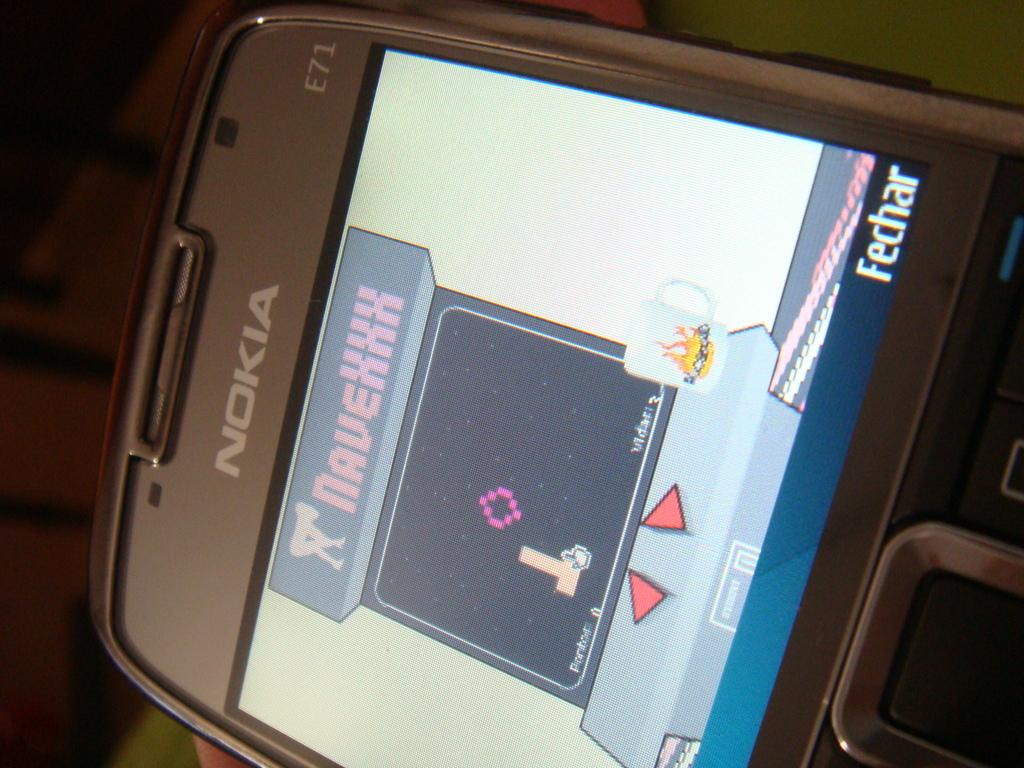What is the brand of this phone?
Offer a terse response. Nokia. What game are they playing?
Provide a succinct answer. Navexxx. 